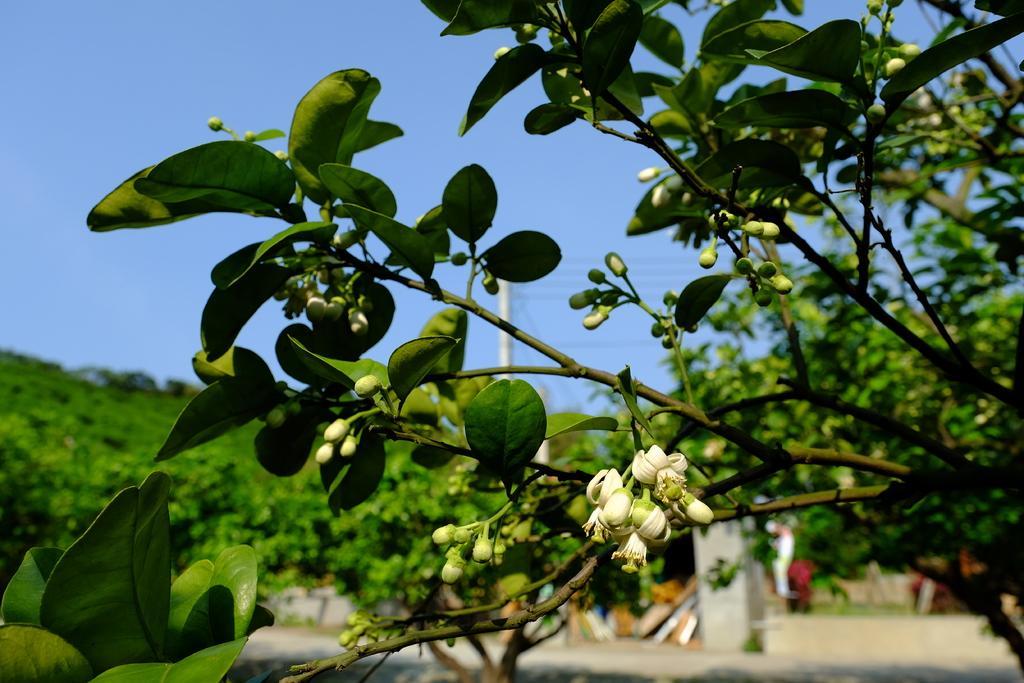Could you give a brief overview of what you see in this image? On the right side, there is a tree which is having white color flowers and green color leaves. In the background, there are trees, a pole which is having electric lines, there is a mountain and there is a blue sky. 